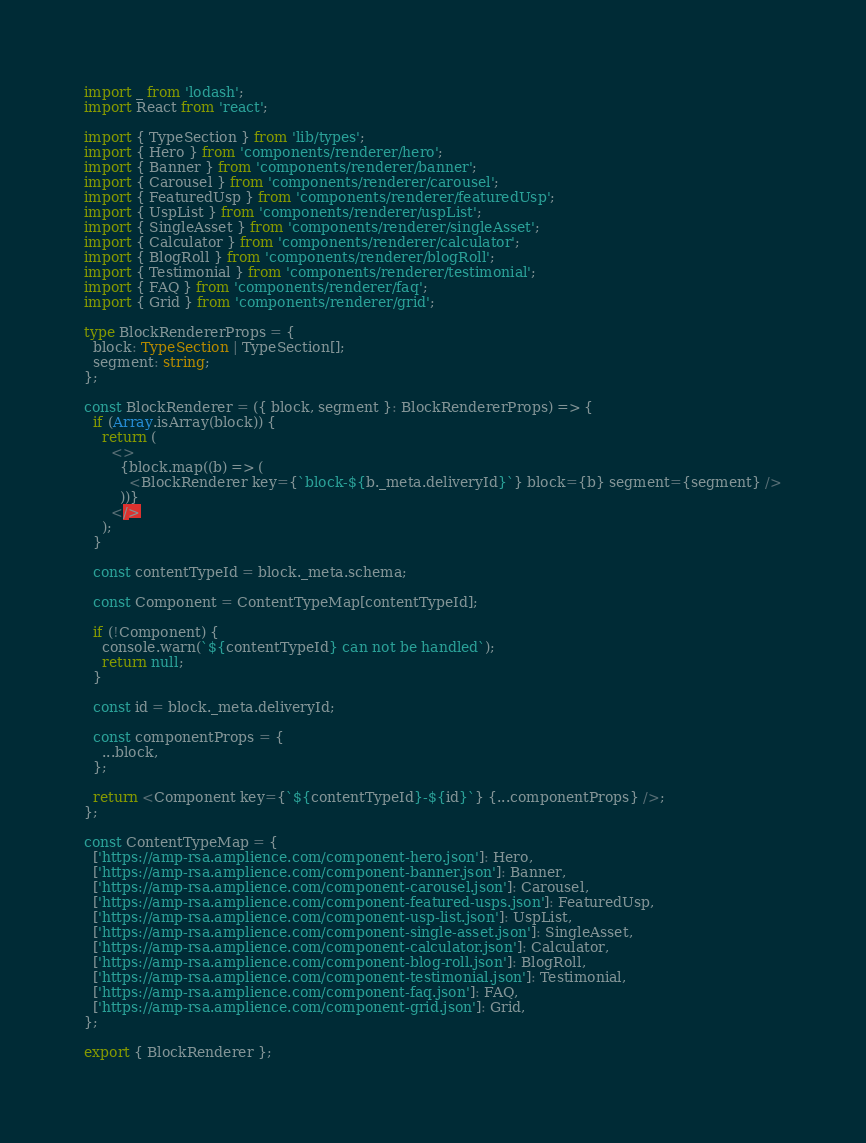Convert code to text. <code><loc_0><loc_0><loc_500><loc_500><_TypeScript_>import _ from 'lodash';
import React from 'react';

import { TypeSection } from 'lib/types';
import { Hero } from 'components/renderer/hero';
import { Banner } from 'components/renderer/banner';
import { Carousel } from 'components/renderer/carousel';
import { FeaturedUsp } from 'components/renderer/featuredUsp';
import { UspList } from 'components/renderer/uspList';
import { SingleAsset } from 'components/renderer/singleAsset';
import { Calculator } from 'components/renderer/calculator';
import { BlogRoll } from 'components/renderer/blogRoll';
import { Testimonial } from 'components/renderer/testimonial';
import { FAQ } from 'components/renderer/faq';
import { Grid } from 'components/renderer/grid';

type BlockRendererProps = {
  block: TypeSection | TypeSection[];
  segment: string;
};

const BlockRenderer = ({ block, segment }: BlockRendererProps) => {
  if (Array.isArray(block)) {
    return (
      <>
        {block.map((b) => (
          <BlockRenderer key={`block-${b._meta.deliveryId}`} block={b} segment={segment} />
        ))}
      </>
    );
  }

  const contentTypeId = block._meta.schema;

  const Component = ContentTypeMap[contentTypeId];

  if (!Component) {
    console.warn(`${contentTypeId} can not be handled`);
    return null;
  }

  const id = block._meta.deliveryId;

  const componentProps = {
    ...block,
  };

  return <Component key={`${contentTypeId}-${id}`} {...componentProps} />;
};

const ContentTypeMap = {
  ['https://amp-rsa.amplience.com/component-hero.json']: Hero,
  ['https://amp-rsa.amplience.com/component-banner.json']: Banner,
  ['https://amp-rsa.amplience.com/component-carousel.json']: Carousel,
  ['https://amp-rsa.amplience.com/component-featured-usps.json']: FeaturedUsp,
  ['https://amp-rsa.amplience.com/component-usp-list.json']: UspList,
  ['https://amp-rsa.amplience.com/component-single-asset.json']: SingleAsset,
  ['https://amp-rsa.amplience.com/component-calculator.json']: Calculator,
  ['https://amp-rsa.amplience.com/component-blog-roll.json']: BlogRoll,
  ['https://amp-rsa.amplience.com/component-testimonial.json']: Testimonial,
  ['https://amp-rsa.amplience.com/component-faq.json']: FAQ,
  ['https://amp-rsa.amplience.com/component-grid.json']: Grid,
};

export { BlockRenderer };
</code> 